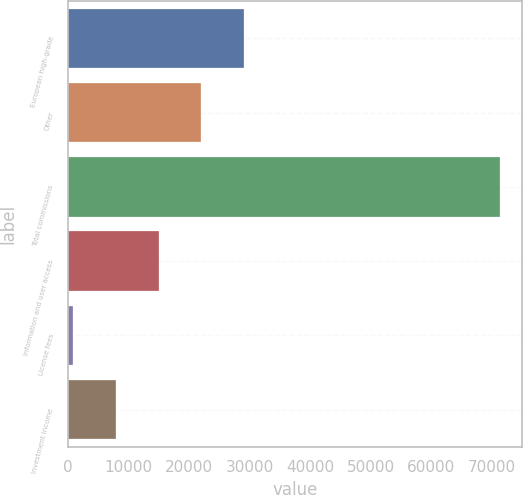Convert chart. <chart><loc_0><loc_0><loc_500><loc_500><bar_chart><fcel>European high-grade<fcel>Other<fcel>Total commissions<fcel>Information and user access<fcel>License fees<fcel>Investment income<nl><fcel>29091.6<fcel>22035.2<fcel>71430<fcel>14978.8<fcel>866<fcel>7922.4<nl></chart> 